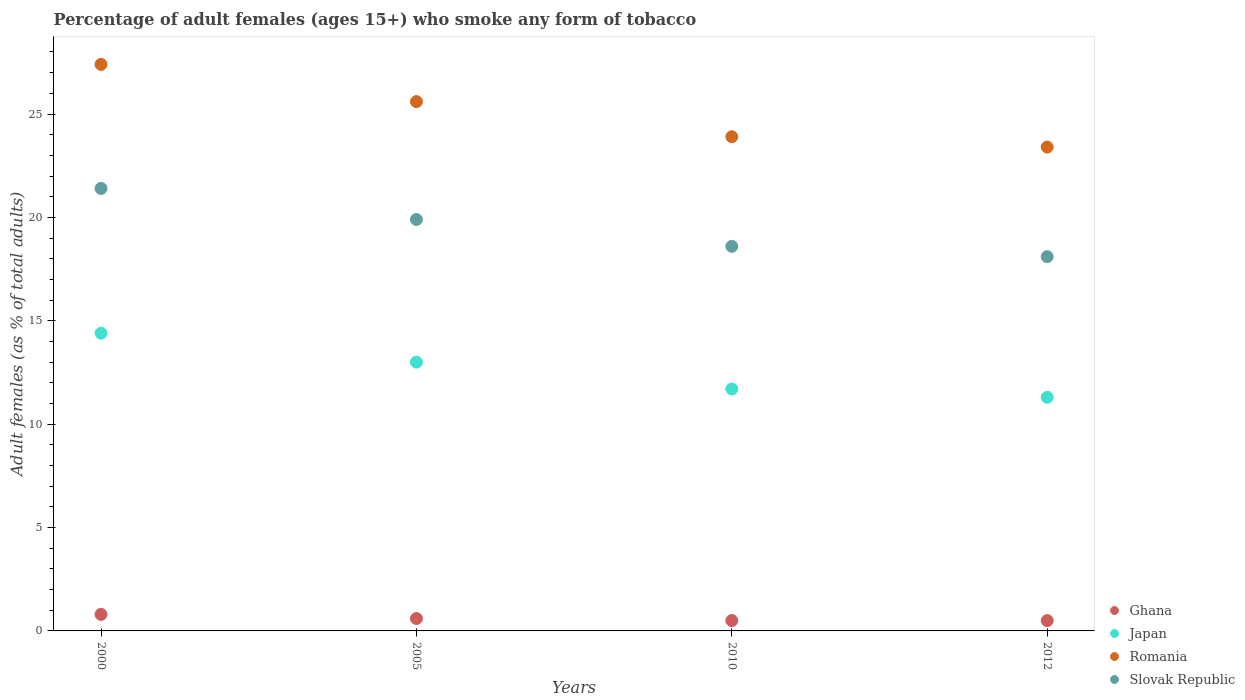How many different coloured dotlines are there?
Ensure brevity in your answer.  4. Is the number of dotlines equal to the number of legend labels?
Make the answer very short. Yes. What is the percentage of adult females who smoke in Romania in 2012?
Ensure brevity in your answer.  23.4. Across all years, what is the minimum percentage of adult females who smoke in Japan?
Your answer should be compact. 11.3. In which year was the percentage of adult females who smoke in Ghana maximum?
Give a very brief answer. 2000. What is the total percentage of adult females who smoke in Ghana in the graph?
Give a very brief answer. 2.4. What is the difference between the percentage of adult females who smoke in Slovak Republic in 2005 and that in 2012?
Your answer should be compact. 1.8. What is the difference between the percentage of adult females who smoke in Slovak Republic in 2000 and the percentage of adult females who smoke in Japan in 2012?
Your answer should be compact. 10.1. In the year 2010, what is the difference between the percentage of adult females who smoke in Romania and percentage of adult females who smoke in Ghana?
Offer a terse response. 23.4. In how many years, is the percentage of adult females who smoke in Romania greater than 19 %?
Provide a succinct answer. 4. What is the ratio of the percentage of adult females who smoke in Japan in 2005 to that in 2012?
Your answer should be very brief. 1.15. Is the difference between the percentage of adult females who smoke in Romania in 2000 and 2005 greater than the difference between the percentage of adult females who smoke in Ghana in 2000 and 2005?
Provide a succinct answer. Yes. What is the difference between the highest and the second highest percentage of adult females who smoke in Romania?
Ensure brevity in your answer.  1.8. What is the difference between the highest and the lowest percentage of adult females who smoke in Japan?
Give a very brief answer. 3.1. Is the sum of the percentage of adult females who smoke in Ghana in 2000 and 2010 greater than the maximum percentage of adult females who smoke in Romania across all years?
Offer a terse response. No. Is the percentage of adult females who smoke in Japan strictly less than the percentage of adult females who smoke in Slovak Republic over the years?
Provide a short and direct response. Yes. How many dotlines are there?
Offer a terse response. 4. How many years are there in the graph?
Your answer should be very brief. 4. What is the difference between two consecutive major ticks on the Y-axis?
Offer a very short reply. 5. Are the values on the major ticks of Y-axis written in scientific E-notation?
Offer a very short reply. No. Does the graph contain any zero values?
Offer a terse response. No. Where does the legend appear in the graph?
Make the answer very short. Bottom right. What is the title of the graph?
Your answer should be compact. Percentage of adult females (ages 15+) who smoke any form of tobacco. Does "Turks and Caicos Islands" appear as one of the legend labels in the graph?
Keep it short and to the point. No. What is the label or title of the Y-axis?
Keep it short and to the point. Adult females (as % of total adults). What is the Adult females (as % of total adults) in Ghana in 2000?
Provide a short and direct response. 0.8. What is the Adult females (as % of total adults) in Romania in 2000?
Your response must be concise. 27.4. What is the Adult females (as % of total adults) of Slovak Republic in 2000?
Give a very brief answer. 21.4. What is the Adult females (as % of total adults) in Japan in 2005?
Your answer should be very brief. 13. What is the Adult females (as % of total adults) of Romania in 2005?
Offer a terse response. 25.6. What is the Adult females (as % of total adults) of Romania in 2010?
Your answer should be compact. 23.9. What is the Adult females (as % of total adults) in Slovak Republic in 2010?
Your answer should be compact. 18.6. What is the Adult females (as % of total adults) in Romania in 2012?
Offer a very short reply. 23.4. What is the Adult females (as % of total adults) in Slovak Republic in 2012?
Your response must be concise. 18.1. Across all years, what is the maximum Adult females (as % of total adults) in Romania?
Provide a short and direct response. 27.4. Across all years, what is the maximum Adult females (as % of total adults) in Slovak Republic?
Give a very brief answer. 21.4. Across all years, what is the minimum Adult females (as % of total adults) in Ghana?
Your answer should be very brief. 0.5. Across all years, what is the minimum Adult females (as % of total adults) in Japan?
Keep it short and to the point. 11.3. Across all years, what is the minimum Adult females (as % of total adults) in Romania?
Your answer should be compact. 23.4. What is the total Adult females (as % of total adults) of Japan in the graph?
Keep it short and to the point. 50.4. What is the total Adult females (as % of total adults) of Romania in the graph?
Your answer should be compact. 100.3. What is the difference between the Adult females (as % of total adults) in Romania in 2000 and that in 2005?
Ensure brevity in your answer.  1.8. What is the difference between the Adult females (as % of total adults) of Romania in 2000 and that in 2010?
Make the answer very short. 3.5. What is the difference between the Adult females (as % of total adults) of Slovak Republic in 2000 and that in 2010?
Ensure brevity in your answer.  2.8. What is the difference between the Adult females (as % of total adults) in Ghana in 2000 and that in 2012?
Ensure brevity in your answer.  0.3. What is the difference between the Adult females (as % of total adults) in Romania in 2000 and that in 2012?
Your response must be concise. 4. What is the difference between the Adult females (as % of total adults) of Slovak Republic in 2000 and that in 2012?
Give a very brief answer. 3.3. What is the difference between the Adult females (as % of total adults) in Romania in 2005 and that in 2010?
Your answer should be compact. 1.7. What is the difference between the Adult females (as % of total adults) of Ghana in 2005 and that in 2012?
Keep it short and to the point. 0.1. What is the difference between the Adult females (as % of total adults) in Japan in 2005 and that in 2012?
Ensure brevity in your answer.  1.7. What is the difference between the Adult females (as % of total adults) of Romania in 2005 and that in 2012?
Ensure brevity in your answer.  2.2. What is the difference between the Adult females (as % of total adults) of Slovak Republic in 2005 and that in 2012?
Give a very brief answer. 1.8. What is the difference between the Adult females (as % of total adults) in Slovak Republic in 2010 and that in 2012?
Your answer should be compact. 0.5. What is the difference between the Adult females (as % of total adults) in Ghana in 2000 and the Adult females (as % of total adults) in Japan in 2005?
Provide a succinct answer. -12.2. What is the difference between the Adult females (as % of total adults) of Ghana in 2000 and the Adult females (as % of total adults) of Romania in 2005?
Provide a short and direct response. -24.8. What is the difference between the Adult females (as % of total adults) of Ghana in 2000 and the Adult females (as % of total adults) of Slovak Republic in 2005?
Give a very brief answer. -19.1. What is the difference between the Adult females (as % of total adults) in Japan in 2000 and the Adult females (as % of total adults) in Romania in 2005?
Give a very brief answer. -11.2. What is the difference between the Adult females (as % of total adults) in Ghana in 2000 and the Adult females (as % of total adults) in Japan in 2010?
Your answer should be very brief. -10.9. What is the difference between the Adult females (as % of total adults) in Ghana in 2000 and the Adult females (as % of total adults) in Romania in 2010?
Provide a short and direct response. -23.1. What is the difference between the Adult females (as % of total adults) in Ghana in 2000 and the Adult females (as % of total adults) in Slovak Republic in 2010?
Give a very brief answer. -17.8. What is the difference between the Adult females (as % of total adults) of Ghana in 2000 and the Adult females (as % of total adults) of Japan in 2012?
Provide a short and direct response. -10.5. What is the difference between the Adult females (as % of total adults) of Ghana in 2000 and the Adult females (as % of total adults) of Romania in 2012?
Your response must be concise. -22.6. What is the difference between the Adult females (as % of total adults) of Ghana in 2000 and the Adult females (as % of total adults) of Slovak Republic in 2012?
Make the answer very short. -17.3. What is the difference between the Adult females (as % of total adults) in Japan in 2000 and the Adult females (as % of total adults) in Romania in 2012?
Your answer should be compact. -9. What is the difference between the Adult females (as % of total adults) in Ghana in 2005 and the Adult females (as % of total adults) in Romania in 2010?
Keep it short and to the point. -23.3. What is the difference between the Adult females (as % of total adults) of Japan in 2005 and the Adult females (as % of total adults) of Romania in 2010?
Offer a very short reply. -10.9. What is the difference between the Adult females (as % of total adults) in Ghana in 2005 and the Adult females (as % of total adults) in Romania in 2012?
Make the answer very short. -22.8. What is the difference between the Adult females (as % of total adults) in Ghana in 2005 and the Adult females (as % of total adults) in Slovak Republic in 2012?
Your answer should be very brief. -17.5. What is the difference between the Adult females (as % of total adults) in Japan in 2005 and the Adult females (as % of total adults) in Romania in 2012?
Offer a very short reply. -10.4. What is the difference between the Adult females (as % of total adults) of Ghana in 2010 and the Adult females (as % of total adults) of Japan in 2012?
Provide a short and direct response. -10.8. What is the difference between the Adult females (as % of total adults) in Ghana in 2010 and the Adult females (as % of total adults) in Romania in 2012?
Offer a very short reply. -22.9. What is the difference between the Adult females (as % of total adults) in Ghana in 2010 and the Adult females (as % of total adults) in Slovak Republic in 2012?
Keep it short and to the point. -17.6. What is the average Adult females (as % of total adults) in Japan per year?
Your answer should be compact. 12.6. What is the average Adult females (as % of total adults) in Romania per year?
Offer a very short reply. 25.07. What is the average Adult females (as % of total adults) in Slovak Republic per year?
Your answer should be compact. 19.5. In the year 2000, what is the difference between the Adult females (as % of total adults) in Ghana and Adult females (as % of total adults) in Japan?
Your response must be concise. -13.6. In the year 2000, what is the difference between the Adult females (as % of total adults) in Ghana and Adult females (as % of total adults) in Romania?
Your response must be concise. -26.6. In the year 2000, what is the difference between the Adult females (as % of total adults) in Ghana and Adult females (as % of total adults) in Slovak Republic?
Offer a terse response. -20.6. In the year 2000, what is the difference between the Adult females (as % of total adults) of Japan and Adult females (as % of total adults) of Slovak Republic?
Provide a succinct answer. -7. In the year 2005, what is the difference between the Adult females (as % of total adults) of Ghana and Adult females (as % of total adults) of Japan?
Keep it short and to the point. -12.4. In the year 2005, what is the difference between the Adult females (as % of total adults) in Ghana and Adult females (as % of total adults) in Slovak Republic?
Make the answer very short. -19.3. In the year 2005, what is the difference between the Adult females (as % of total adults) in Japan and Adult females (as % of total adults) in Romania?
Your answer should be very brief. -12.6. In the year 2010, what is the difference between the Adult females (as % of total adults) in Ghana and Adult females (as % of total adults) in Japan?
Give a very brief answer. -11.2. In the year 2010, what is the difference between the Adult females (as % of total adults) in Ghana and Adult females (as % of total adults) in Romania?
Your answer should be very brief. -23.4. In the year 2010, what is the difference between the Adult females (as % of total adults) of Ghana and Adult females (as % of total adults) of Slovak Republic?
Offer a very short reply. -18.1. In the year 2010, what is the difference between the Adult females (as % of total adults) in Japan and Adult females (as % of total adults) in Romania?
Provide a short and direct response. -12.2. In the year 2010, what is the difference between the Adult females (as % of total adults) in Japan and Adult females (as % of total adults) in Slovak Republic?
Provide a succinct answer. -6.9. In the year 2012, what is the difference between the Adult females (as % of total adults) in Ghana and Adult females (as % of total adults) in Japan?
Your answer should be very brief. -10.8. In the year 2012, what is the difference between the Adult females (as % of total adults) in Ghana and Adult females (as % of total adults) in Romania?
Provide a short and direct response. -22.9. In the year 2012, what is the difference between the Adult females (as % of total adults) in Ghana and Adult females (as % of total adults) in Slovak Republic?
Give a very brief answer. -17.6. In the year 2012, what is the difference between the Adult females (as % of total adults) of Japan and Adult females (as % of total adults) of Romania?
Provide a short and direct response. -12.1. In the year 2012, what is the difference between the Adult females (as % of total adults) in Japan and Adult females (as % of total adults) in Slovak Republic?
Offer a terse response. -6.8. What is the ratio of the Adult females (as % of total adults) of Japan in 2000 to that in 2005?
Your answer should be very brief. 1.11. What is the ratio of the Adult females (as % of total adults) in Romania in 2000 to that in 2005?
Keep it short and to the point. 1.07. What is the ratio of the Adult females (as % of total adults) of Slovak Republic in 2000 to that in 2005?
Offer a terse response. 1.08. What is the ratio of the Adult females (as % of total adults) of Ghana in 2000 to that in 2010?
Provide a succinct answer. 1.6. What is the ratio of the Adult females (as % of total adults) of Japan in 2000 to that in 2010?
Offer a terse response. 1.23. What is the ratio of the Adult females (as % of total adults) in Romania in 2000 to that in 2010?
Make the answer very short. 1.15. What is the ratio of the Adult females (as % of total adults) in Slovak Republic in 2000 to that in 2010?
Your answer should be compact. 1.15. What is the ratio of the Adult females (as % of total adults) of Japan in 2000 to that in 2012?
Provide a succinct answer. 1.27. What is the ratio of the Adult females (as % of total adults) of Romania in 2000 to that in 2012?
Make the answer very short. 1.17. What is the ratio of the Adult females (as % of total adults) of Slovak Republic in 2000 to that in 2012?
Your answer should be compact. 1.18. What is the ratio of the Adult females (as % of total adults) in Ghana in 2005 to that in 2010?
Keep it short and to the point. 1.2. What is the ratio of the Adult females (as % of total adults) in Romania in 2005 to that in 2010?
Offer a terse response. 1.07. What is the ratio of the Adult females (as % of total adults) of Slovak Republic in 2005 to that in 2010?
Your answer should be very brief. 1.07. What is the ratio of the Adult females (as % of total adults) in Japan in 2005 to that in 2012?
Offer a very short reply. 1.15. What is the ratio of the Adult females (as % of total adults) of Romania in 2005 to that in 2012?
Offer a very short reply. 1.09. What is the ratio of the Adult females (as % of total adults) in Slovak Republic in 2005 to that in 2012?
Your answer should be very brief. 1.1. What is the ratio of the Adult females (as % of total adults) of Japan in 2010 to that in 2012?
Keep it short and to the point. 1.04. What is the ratio of the Adult females (as % of total adults) in Romania in 2010 to that in 2012?
Your response must be concise. 1.02. What is the ratio of the Adult females (as % of total adults) of Slovak Republic in 2010 to that in 2012?
Keep it short and to the point. 1.03. What is the difference between the highest and the second highest Adult females (as % of total adults) in Ghana?
Keep it short and to the point. 0.2. What is the difference between the highest and the second highest Adult females (as % of total adults) of Japan?
Ensure brevity in your answer.  1.4. What is the difference between the highest and the lowest Adult females (as % of total adults) of Ghana?
Your answer should be compact. 0.3. What is the difference between the highest and the lowest Adult females (as % of total adults) in Japan?
Offer a terse response. 3.1. What is the difference between the highest and the lowest Adult females (as % of total adults) in Romania?
Your response must be concise. 4. 